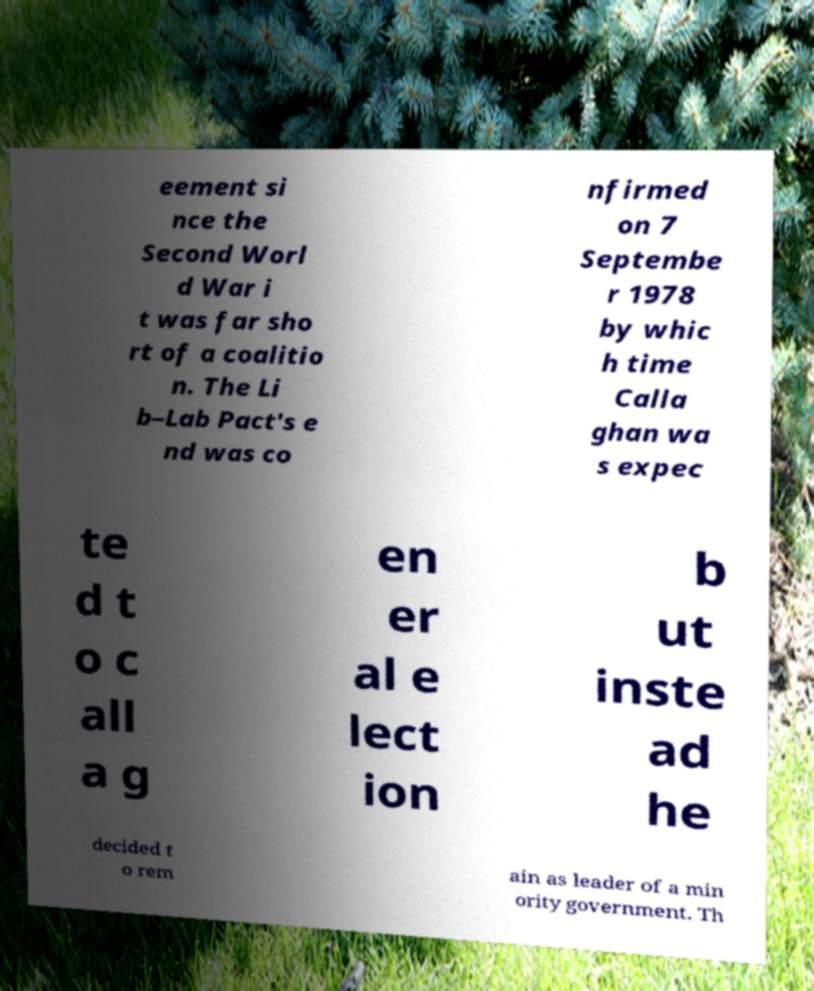Can you read and provide the text displayed in the image?This photo seems to have some interesting text. Can you extract and type it out for me? eement si nce the Second Worl d War i t was far sho rt of a coalitio n. The Li b–Lab Pact's e nd was co nfirmed on 7 Septembe r 1978 by whic h time Calla ghan wa s expec te d t o c all a g en er al e lect ion b ut inste ad he decided t o rem ain as leader of a min ority government. Th 